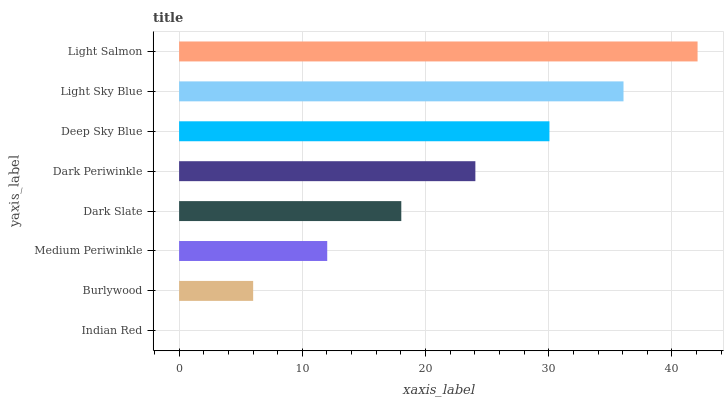Is Indian Red the minimum?
Answer yes or no. Yes. Is Light Salmon the maximum?
Answer yes or no. Yes. Is Burlywood the minimum?
Answer yes or no. No. Is Burlywood the maximum?
Answer yes or no. No. Is Burlywood greater than Indian Red?
Answer yes or no. Yes. Is Indian Red less than Burlywood?
Answer yes or no. Yes. Is Indian Red greater than Burlywood?
Answer yes or no. No. Is Burlywood less than Indian Red?
Answer yes or no. No. Is Dark Periwinkle the high median?
Answer yes or no. Yes. Is Dark Slate the low median?
Answer yes or no. Yes. Is Deep Sky Blue the high median?
Answer yes or no. No. Is Deep Sky Blue the low median?
Answer yes or no. No. 